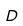<formula> <loc_0><loc_0><loc_500><loc_500>D</formula> 